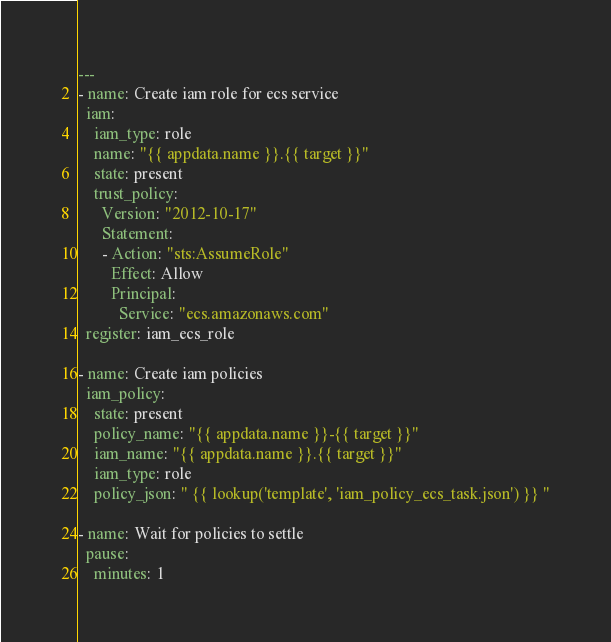<code> <loc_0><loc_0><loc_500><loc_500><_YAML_>---
- name: Create iam role for ecs service
  iam:
    iam_type: role
    name: "{{ appdata.name }}.{{ target }}"
    state: present
    trust_policy:
      Version: "2012-10-17"
      Statement:
      - Action: "sts:AssumeRole"
        Effect: Allow
        Principal:
          Service: "ecs.amazonaws.com"
  register: iam_ecs_role

- name: Create iam policies
  iam_policy:
    state: present
    policy_name: "{{ appdata.name }}-{{ target }}"
    iam_name: "{{ appdata.name }}.{{ target }}"
    iam_type: role
    policy_json: " {{ lookup('template', 'iam_policy_ecs_task.json') }} "

- name: Wait for policies to settle
  pause:
    minutes: 1
</code> 